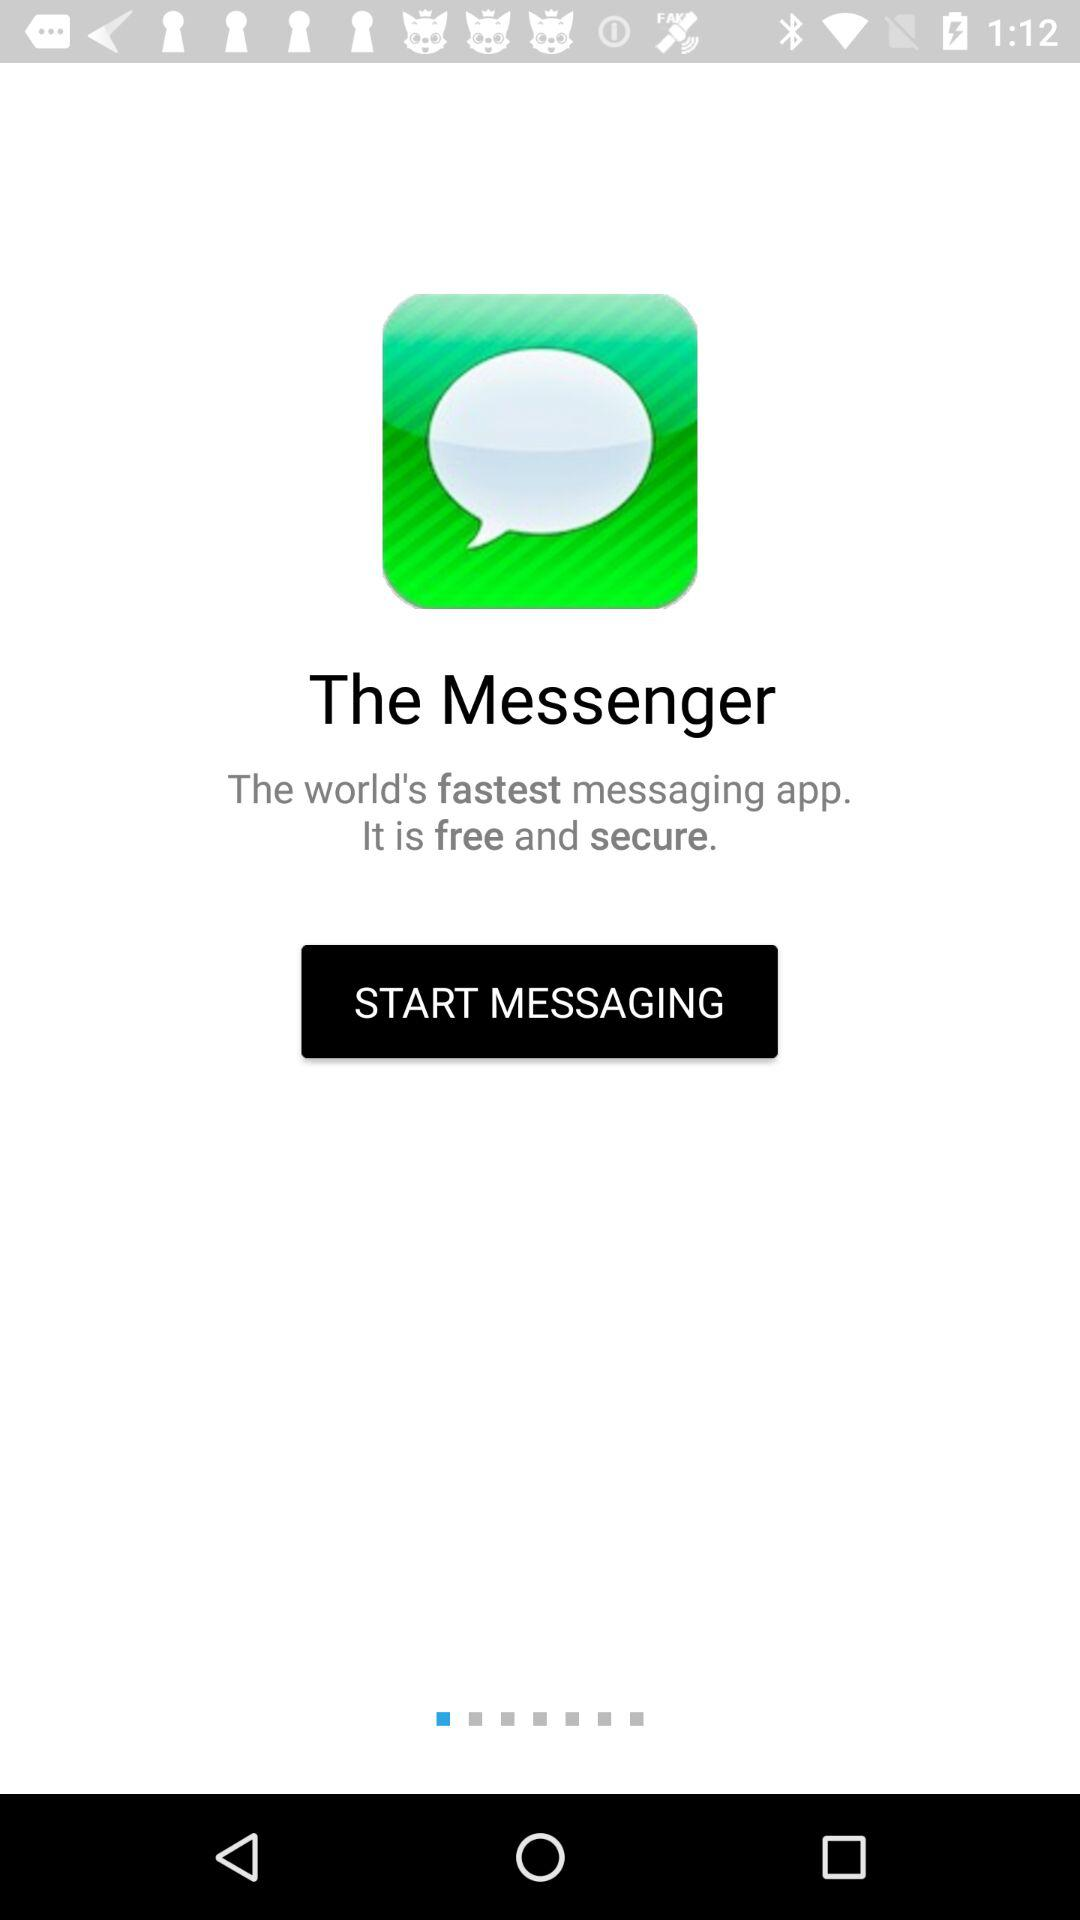What is the app's name? The app's name is "The Messenger". 